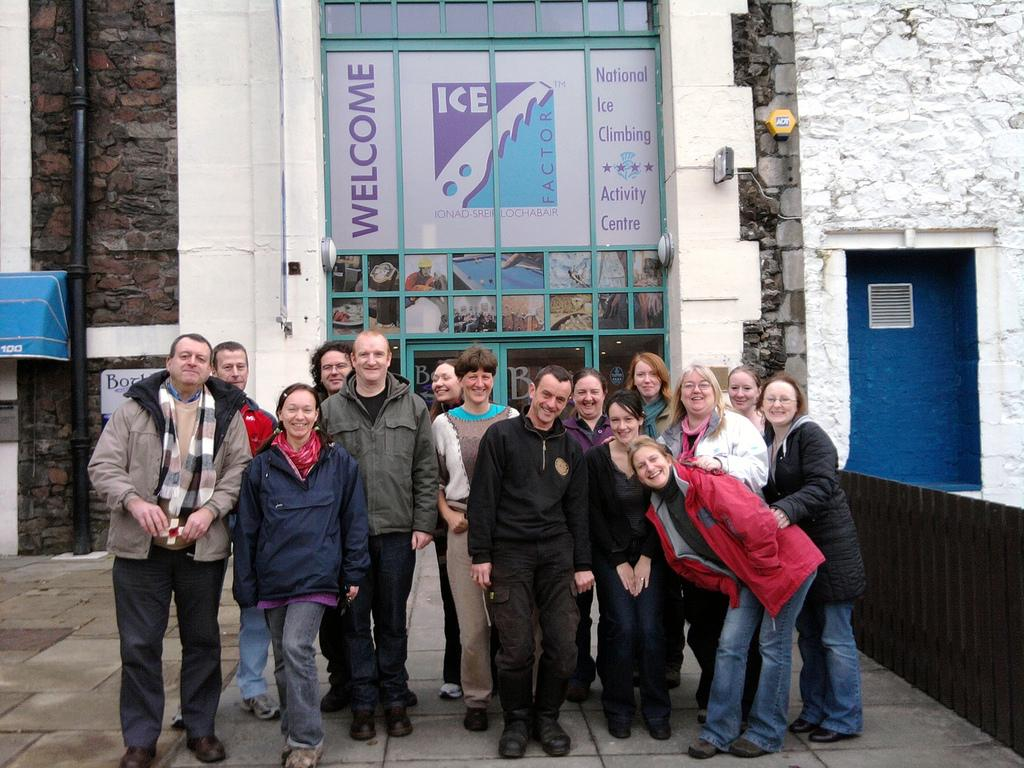What are the people in the image doing? The people in the image are standing and smiling. Where are the people standing? They are standing on a road. What can be seen in the background of the image? There are buildings, a pipeline, a fence, and an advertisement visible in the background. What type of rake is being used to clean the dirt in the image? There is no rake or dirt present in the image. What kind of kettle can be seen boiling water in the background? There is no kettle or water-boiling activity in the image. 